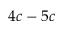Convert formula to latex. <formula><loc_0><loc_0><loc_500><loc_500>4 c - 5 c</formula> 